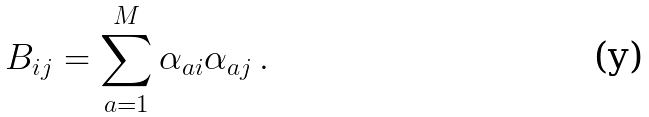<formula> <loc_0><loc_0><loc_500><loc_500>B _ { i j } = \sum _ { a = 1 } ^ { M } \alpha _ { a i } \alpha _ { a j } \, .</formula> 